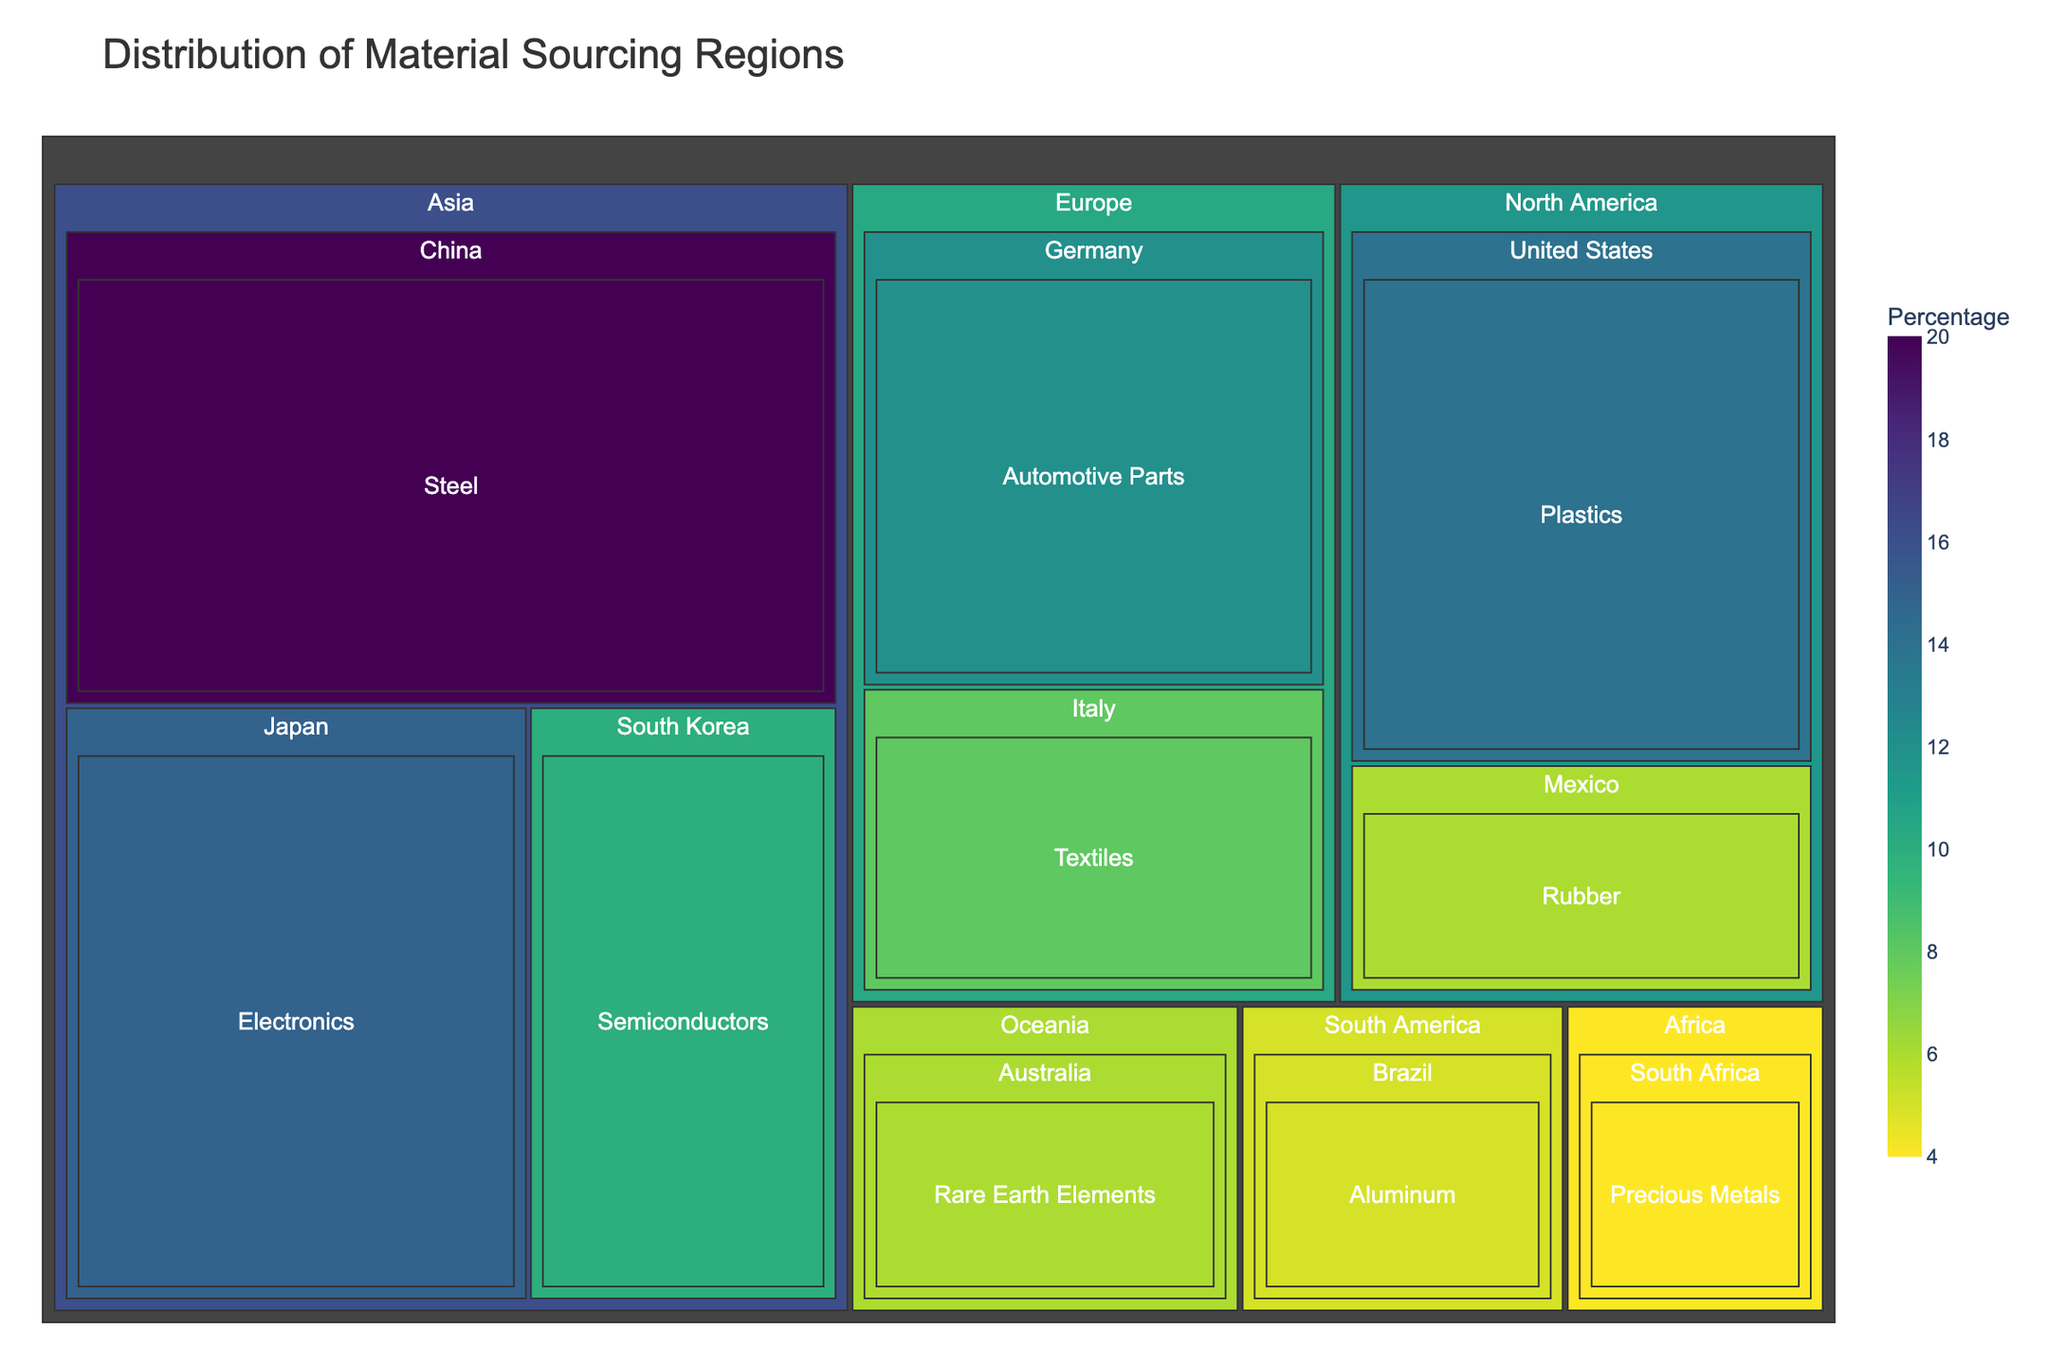What's the title of the treemap? The title of the treemap is displayed at the top of the figure.
Answer: Distribution of Material Sourcing Regions How many regions are included in the treemap? The treemap visually shows the regions as the highest hierarchical level. By counting the distinct rectangular sections at this level, we can determine the number of regions.
Answer: 5 Which country from Asia contributes the most in percentage? In the "Asia" section of the treemap, we can compare the percentages of all countries. China has the largest rectangle in the "Asia" section.
Answer: China Which material has the smallest percentage contribution, and from which region and country is it sourced? By comparing the sizes of all rectangles across the treemap, the smallest rectangle represents the smallest percentage. The smallest percentage is for “Precious Metals” from South Africa in the "Africa" region.
Answer: Precious Metals from South Africa in Africa What is the combined percentage of materials sourced from North America? Within the "North America" section of the treemap, add the percentages of all countries visible: United States (14%) and Mexico (6%). The combined percentage is 14 + 6.
Answer: 20% Compare the percentages of materials sourced from Europe and South America. Which region sources more, and by how much? Sum the percentages for Europe (Germany 12% + Italy 8%) and South America (Brazil 5%). Then find the difference. Europe sources more: 20 - 5 = 15.
Answer: Europe sources 15% more than South America Which region sources the highest percentage of materials, and what is the main material in that region? The region with the largest aggregation of percentages indicates the highest sourcing. In the "Asia" section, adding the percentages (20% + 15% + 10%) shows 45%, making it the highest. China, with Steel, is the main material source in Asia.
Answer: Asia, Steel What is the percentage difference between the materials sourced from Oceania and Africa? Locate Oceania (Australia, 6%) and Africa (South Africa, 4%) regions. Calculate the difference between these percentages: 6 - 4.
Answer: 2% How many countries contribute to the material sourcing for the company? Each rectangle nested within the regions represents a different country. Counting these rectangles gives the total number of contributing countries.
Answer: 10 Which region has the most diverse range of sourced materials, and how many different materials does it source? Explore regions and notice the number of distinct materials listed under each. Asia has materials from China (Steel), Japan (Electronics), and South Korea (Semiconductors), contributing to three distinct materials.
Answer: Asia, 3 materials 